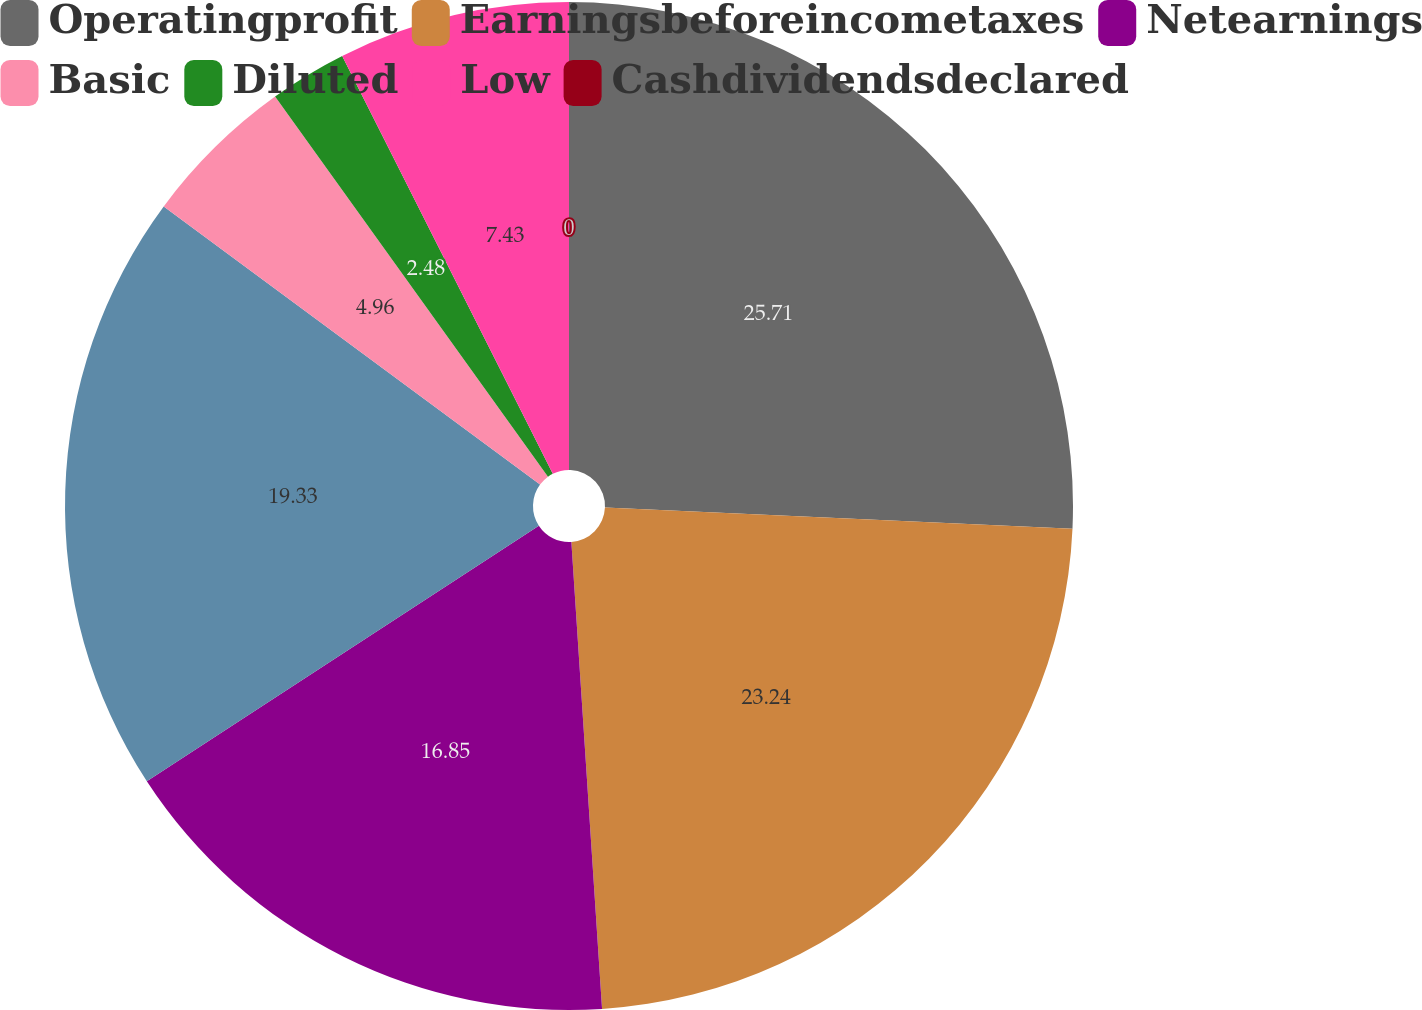<chart> <loc_0><loc_0><loc_500><loc_500><pie_chart><fcel>Operatingprofit<fcel>Earningsbeforeincometaxes<fcel>Netearnings<fcel>Unnamed: 3<fcel>Basic<fcel>Diluted<fcel>Low<fcel>Cashdividendsdeclared<nl><fcel>25.72%<fcel>23.24%<fcel>16.85%<fcel>19.33%<fcel>4.96%<fcel>2.48%<fcel>7.43%<fcel>0.0%<nl></chart> 